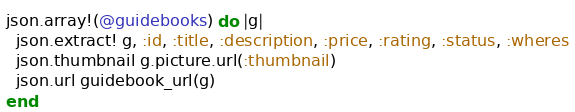Convert code to text. <code><loc_0><loc_0><loc_500><loc_500><_Ruby_>json.array!(@guidebooks) do |g|
  json.extract! g, :id, :title, :description, :price, :rating, :status, :wheres
  json.thumbnail g.picture.url(:thumbnail)
  json.url guidebook_url(g)
end
</code> 